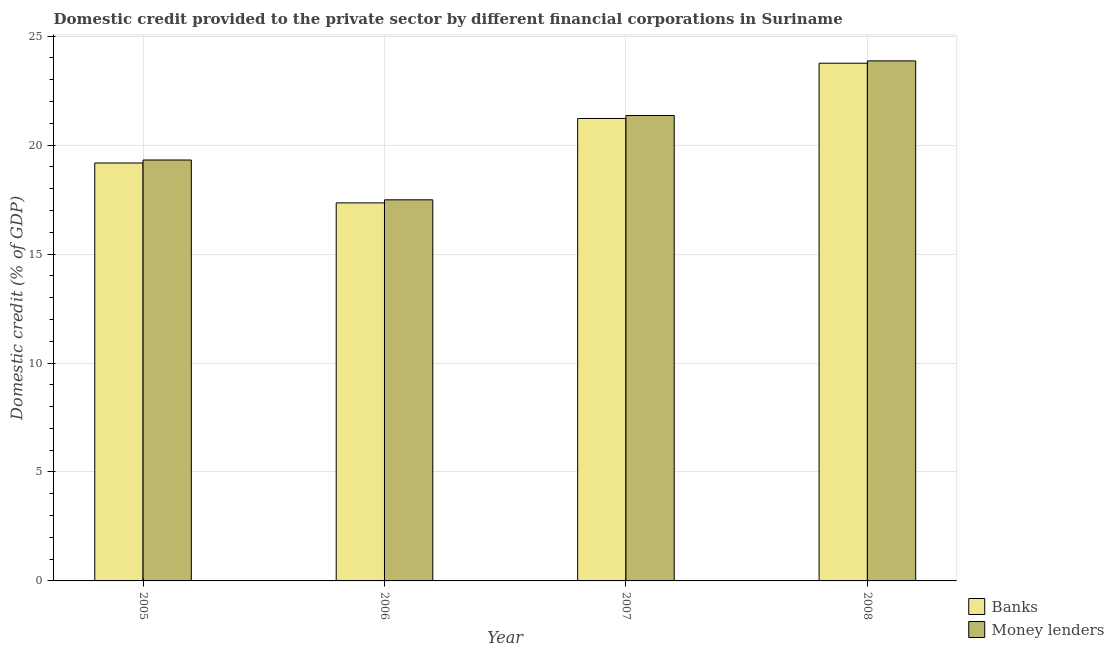How many different coloured bars are there?
Your answer should be very brief. 2. How many groups of bars are there?
Make the answer very short. 4. Are the number of bars per tick equal to the number of legend labels?
Your answer should be compact. Yes. Are the number of bars on each tick of the X-axis equal?
Offer a very short reply. Yes. What is the label of the 4th group of bars from the left?
Your response must be concise. 2008. What is the domestic credit provided by money lenders in 2006?
Offer a terse response. 17.49. Across all years, what is the maximum domestic credit provided by banks?
Provide a succinct answer. 23.76. Across all years, what is the minimum domestic credit provided by money lenders?
Give a very brief answer. 17.49. In which year was the domestic credit provided by banks minimum?
Keep it short and to the point. 2006. What is the total domestic credit provided by banks in the graph?
Provide a succinct answer. 81.5. What is the difference between the domestic credit provided by banks in 2006 and that in 2007?
Provide a short and direct response. -3.87. What is the difference between the domestic credit provided by money lenders in 2008 and the domestic credit provided by banks in 2006?
Your answer should be very brief. 6.38. What is the average domestic credit provided by money lenders per year?
Offer a very short reply. 20.51. In the year 2005, what is the difference between the domestic credit provided by money lenders and domestic credit provided by banks?
Provide a short and direct response. 0. In how many years, is the domestic credit provided by banks greater than 20 %?
Your response must be concise. 2. What is the ratio of the domestic credit provided by banks in 2005 to that in 2008?
Make the answer very short. 0.81. Is the domestic credit provided by banks in 2006 less than that in 2008?
Offer a very short reply. Yes. Is the difference between the domestic credit provided by banks in 2005 and 2007 greater than the difference between the domestic credit provided by money lenders in 2005 and 2007?
Your response must be concise. No. What is the difference between the highest and the second highest domestic credit provided by banks?
Offer a very short reply. 2.54. What is the difference between the highest and the lowest domestic credit provided by banks?
Your answer should be compact. 6.41. Is the sum of the domestic credit provided by money lenders in 2005 and 2007 greater than the maximum domestic credit provided by banks across all years?
Your response must be concise. Yes. What does the 2nd bar from the left in 2005 represents?
Your response must be concise. Money lenders. What does the 2nd bar from the right in 2007 represents?
Your answer should be compact. Banks. Are all the bars in the graph horizontal?
Make the answer very short. No. What is the difference between two consecutive major ticks on the Y-axis?
Offer a very short reply. 5. Are the values on the major ticks of Y-axis written in scientific E-notation?
Make the answer very short. No. How many legend labels are there?
Your answer should be compact. 2. How are the legend labels stacked?
Your answer should be very brief. Vertical. What is the title of the graph?
Make the answer very short. Domestic credit provided to the private sector by different financial corporations in Suriname. What is the label or title of the Y-axis?
Make the answer very short. Domestic credit (% of GDP). What is the Domestic credit (% of GDP) in Banks in 2005?
Keep it short and to the point. 19.18. What is the Domestic credit (% of GDP) in Money lenders in 2005?
Offer a very short reply. 19.32. What is the Domestic credit (% of GDP) of Banks in 2006?
Offer a terse response. 17.35. What is the Domestic credit (% of GDP) of Money lenders in 2006?
Offer a terse response. 17.49. What is the Domestic credit (% of GDP) in Banks in 2007?
Your response must be concise. 21.22. What is the Domestic credit (% of GDP) in Money lenders in 2007?
Your answer should be very brief. 21.36. What is the Domestic credit (% of GDP) in Banks in 2008?
Offer a very short reply. 23.76. What is the Domestic credit (% of GDP) of Money lenders in 2008?
Give a very brief answer. 23.86. Across all years, what is the maximum Domestic credit (% of GDP) of Banks?
Ensure brevity in your answer.  23.76. Across all years, what is the maximum Domestic credit (% of GDP) of Money lenders?
Keep it short and to the point. 23.86. Across all years, what is the minimum Domestic credit (% of GDP) in Banks?
Offer a very short reply. 17.35. Across all years, what is the minimum Domestic credit (% of GDP) in Money lenders?
Provide a short and direct response. 17.49. What is the total Domestic credit (% of GDP) of Banks in the graph?
Your answer should be very brief. 81.5. What is the total Domestic credit (% of GDP) of Money lenders in the graph?
Keep it short and to the point. 82.03. What is the difference between the Domestic credit (% of GDP) in Banks in 2005 and that in 2006?
Offer a terse response. 1.83. What is the difference between the Domestic credit (% of GDP) in Money lenders in 2005 and that in 2006?
Keep it short and to the point. 1.83. What is the difference between the Domestic credit (% of GDP) in Banks in 2005 and that in 2007?
Provide a succinct answer. -2.04. What is the difference between the Domestic credit (% of GDP) in Money lenders in 2005 and that in 2007?
Your response must be concise. -2.04. What is the difference between the Domestic credit (% of GDP) of Banks in 2005 and that in 2008?
Offer a terse response. -4.58. What is the difference between the Domestic credit (% of GDP) of Money lenders in 2005 and that in 2008?
Keep it short and to the point. -4.55. What is the difference between the Domestic credit (% of GDP) in Banks in 2006 and that in 2007?
Ensure brevity in your answer.  -3.87. What is the difference between the Domestic credit (% of GDP) in Money lenders in 2006 and that in 2007?
Keep it short and to the point. -3.87. What is the difference between the Domestic credit (% of GDP) in Banks in 2006 and that in 2008?
Your answer should be very brief. -6.41. What is the difference between the Domestic credit (% of GDP) of Money lenders in 2006 and that in 2008?
Your answer should be compact. -6.38. What is the difference between the Domestic credit (% of GDP) in Banks in 2007 and that in 2008?
Your response must be concise. -2.54. What is the difference between the Domestic credit (% of GDP) in Money lenders in 2007 and that in 2008?
Your answer should be compact. -2.51. What is the difference between the Domestic credit (% of GDP) in Banks in 2005 and the Domestic credit (% of GDP) in Money lenders in 2006?
Offer a terse response. 1.69. What is the difference between the Domestic credit (% of GDP) in Banks in 2005 and the Domestic credit (% of GDP) in Money lenders in 2007?
Make the answer very short. -2.18. What is the difference between the Domestic credit (% of GDP) of Banks in 2005 and the Domestic credit (% of GDP) of Money lenders in 2008?
Give a very brief answer. -4.69. What is the difference between the Domestic credit (% of GDP) in Banks in 2006 and the Domestic credit (% of GDP) in Money lenders in 2007?
Keep it short and to the point. -4.01. What is the difference between the Domestic credit (% of GDP) of Banks in 2006 and the Domestic credit (% of GDP) of Money lenders in 2008?
Provide a short and direct response. -6.52. What is the difference between the Domestic credit (% of GDP) of Banks in 2007 and the Domestic credit (% of GDP) of Money lenders in 2008?
Provide a short and direct response. -2.64. What is the average Domestic credit (% of GDP) of Banks per year?
Your answer should be compact. 20.38. What is the average Domestic credit (% of GDP) in Money lenders per year?
Keep it short and to the point. 20.51. In the year 2005, what is the difference between the Domestic credit (% of GDP) of Banks and Domestic credit (% of GDP) of Money lenders?
Give a very brief answer. -0.14. In the year 2006, what is the difference between the Domestic credit (% of GDP) in Banks and Domestic credit (% of GDP) in Money lenders?
Make the answer very short. -0.14. In the year 2007, what is the difference between the Domestic credit (% of GDP) of Banks and Domestic credit (% of GDP) of Money lenders?
Ensure brevity in your answer.  -0.14. In the year 2008, what is the difference between the Domestic credit (% of GDP) of Banks and Domestic credit (% of GDP) of Money lenders?
Give a very brief answer. -0.11. What is the ratio of the Domestic credit (% of GDP) of Banks in 2005 to that in 2006?
Your response must be concise. 1.11. What is the ratio of the Domestic credit (% of GDP) in Money lenders in 2005 to that in 2006?
Offer a terse response. 1.1. What is the ratio of the Domestic credit (% of GDP) of Banks in 2005 to that in 2007?
Your answer should be compact. 0.9. What is the ratio of the Domestic credit (% of GDP) of Money lenders in 2005 to that in 2007?
Give a very brief answer. 0.9. What is the ratio of the Domestic credit (% of GDP) of Banks in 2005 to that in 2008?
Provide a short and direct response. 0.81. What is the ratio of the Domestic credit (% of GDP) in Money lenders in 2005 to that in 2008?
Your answer should be very brief. 0.81. What is the ratio of the Domestic credit (% of GDP) of Banks in 2006 to that in 2007?
Offer a terse response. 0.82. What is the ratio of the Domestic credit (% of GDP) in Money lenders in 2006 to that in 2007?
Provide a short and direct response. 0.82. What is the ratio of the Domestic credit (% of GDP) in Banks in 2006 to that in 2008?
Provide a succinct answer. 0.73. What is the ratio of the Domestic credit (% of GDP) in Money lenders in 2006 to that in 2008?
Provide a short and direct response. 0.73. What is the ratio of the Domestic credit (% of GDP) of Banks in 2007 to that in 2008?
Provide a short and direct response. 0.89. What is the ratio of the Domestic credit (% of GDP) in Money lenders in 2007 to that in 2008?
Offer a terse response. 0.9. What is the difference between the highest and the second highest Domestic credit (% of GDP) in Banks?
Give a very brief answer. 2.54. What is the difference between the highest and the second highest Domestic credit (% of GDP) in Money lenders?
Offer a very short reply. 2.51. What is the difference between the highest and the lowest Domestic credit (% of GDP) of Banks?
Give a very brief answer. 6.41. What is the difference between the highest and the lowest Domestic credit (% of GDP) in Money lenders?
Make the answer very short. 6.38. 